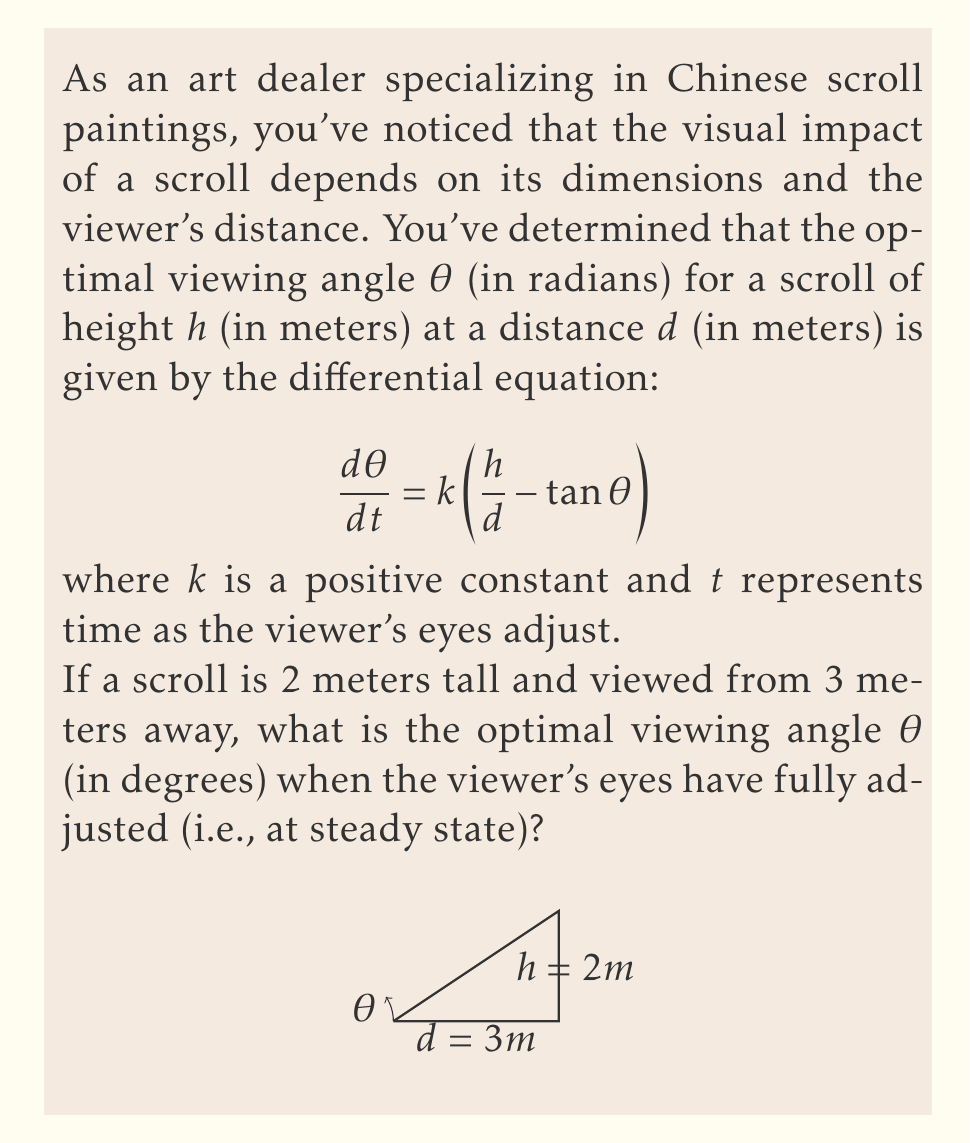Could you help me with this problem? Let's approach this step-by-step:

1) At steady state, $\frac{d\theta}{dt} = 0$. So we can set the right side of the equation to zero:

   $$0 = k\left(\frac{h}{d} - \tan\theta\right)$$

2) Since k is a positive constant, this implies:

   $$\frac{h}{d} = \tan\theta$$

3) We're given that h = 2 meters and d = 3 meters. Let's substitute these values:

   $$\frac{2}{3} = \tan\theta$$

4) To solve for θ, we need to take the inverse tangent (arctan) of both sides:

   $$\theta = \arctan\left(\frac{2}{3}\right)$$

5) This gives us θ in radians. To convert to degrees, we multiply by $\frac{180}{\pi}$:

   $$\theta = \arctan\left(\frac{2}{3}\right) \cdot \frac{180}{\pi}$$

6) Calculating this:

   $$\theta \approx 33.69^\circ$$

Therefore, the optimal viewing angle is approximately 33.69 degrees.
Answer: $33.69^\circ$ 